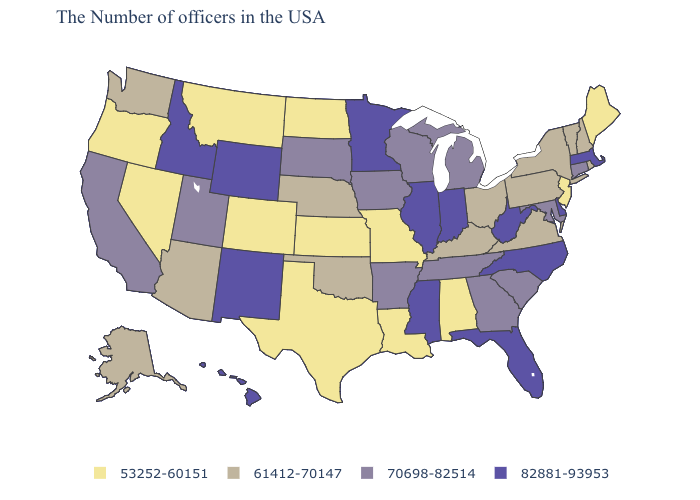Name the states that have a value in the range 82881-93953?
Concise answer only. Massachusetts, Delaware, North Carolina, West Virginia, Florida, Indiana, Illinois, Mississippi, Minnesota, Wyoming, New Mexico, Idaho, Hawaii. Among the states that border Florida , which have the lowest value?
Short answer required. Alabama. What is the value of West Virginia?
Write a very short answer. 82881-93953. Among the states that border Arizona , which have the highest value?
Quick response, please. New Mexico. Is the legend a continuous bar?
Quick response, please. No. Does Utah have the highest value in the USA?
Short answer required. No. What is the value of New York?
Answer briefly. 61412-70147. Name the states that have a value in the range 61412-70147?
Write a very short answer. Rhode Island, New Hampshire, Vermont, New York, Pennsylvania, Virginia, Ohio, Kentucky, Nebraska, Oklahoma, Arizona, Washington, Alaska. Name the states that have a value in the range 82881-93953?
Concise answer only. Massachusetts, Delaware, North Carolina, West Virginia, Florida, Indiana, Illinois, Mississippi, Minnesota, Wyoming, New Mexico, Idaho, Hawaii. Does Ohio have a lower value than Maryland?
Give a very brief answer. Yes. Does the map have missing data?
Be succinct. No. Does New Mexico have the highest value in the West?
Short answer required. Yes. Among the states that border Idaho , which have the lowest value?
Short answer required. Montana, Nevada, Oregon. What is the value of New Mexico?
Quick response, please. 82881-93953. What is the value of Kentucky?
Keep it brief. 61412-70147. 